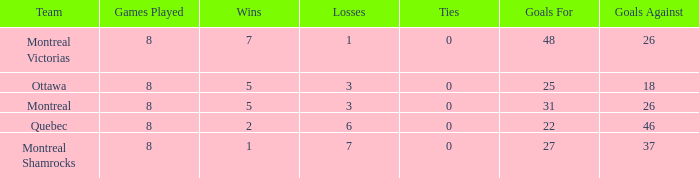For teams with 7 wins, what is the number of goals against? 26.0. 